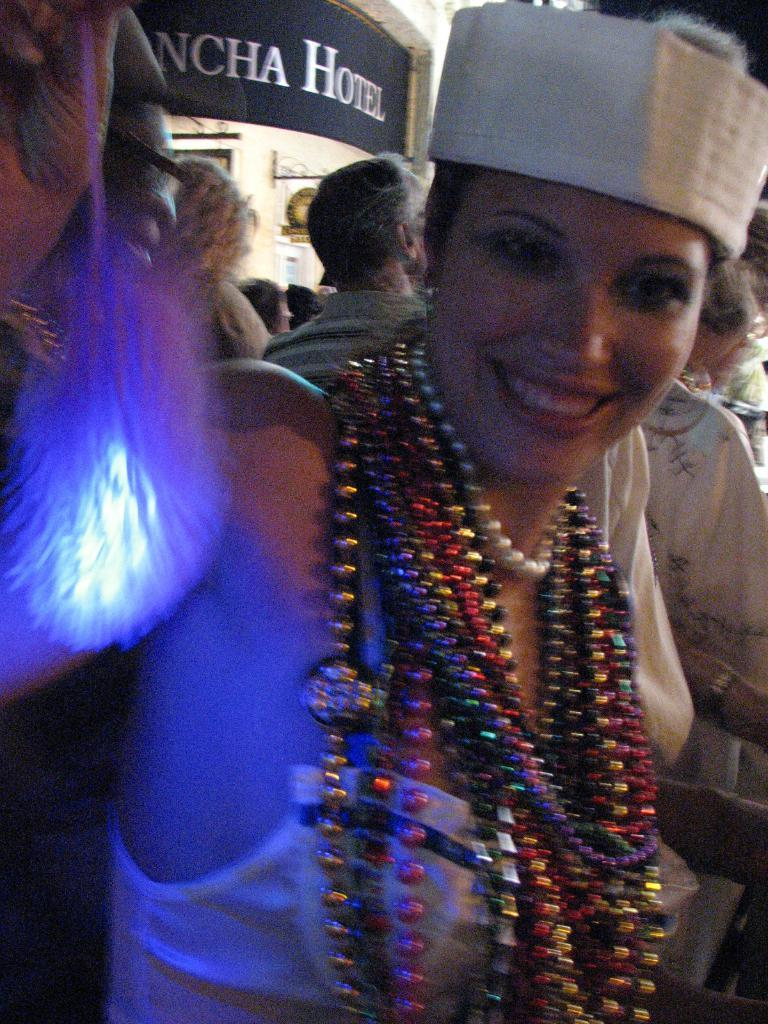How many people are in the image? There are persons in the image. Can you describe the woman in the front of the image? The woman in the front of the image is wearing multiple chains. What can be seen in the background of the image? There is a store visible in the image. Where is the light coming from in the image? There is light on the left side of the image. What is the team's average income in the image? There is no team or income information present in the image. How many nuts are visible on the woman's outfit in the image? There are no nuts visible on the woman's outfit in the image; she is wearing multiple chains. 